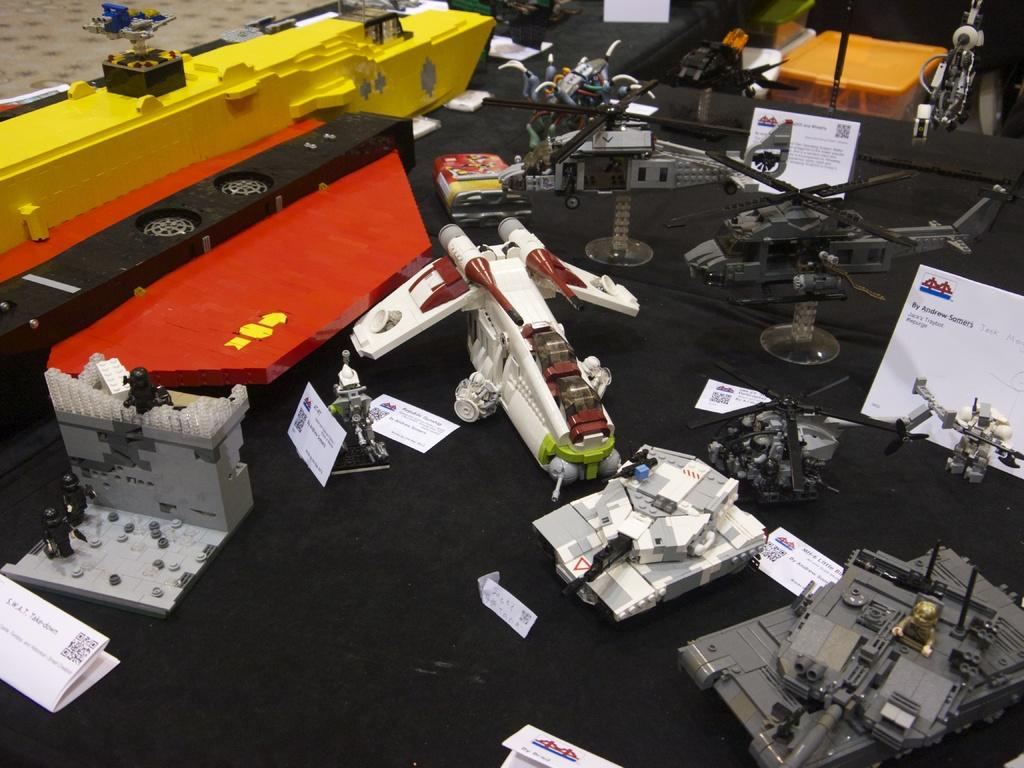Where was the image taken? The image was taken indoors. What piece of furniture is present in the image? There is a table in the image. What is covering the table? The table has a tablecloth. What is placed on top of the table? There are boards with text and many toys on the table. How many trains can be seen on the table in the image? There are no trains visible on the table in the image. What color is the ladybug that is crawling on the tablecloth? There is no ladybug present on the tablecloth in the image. 